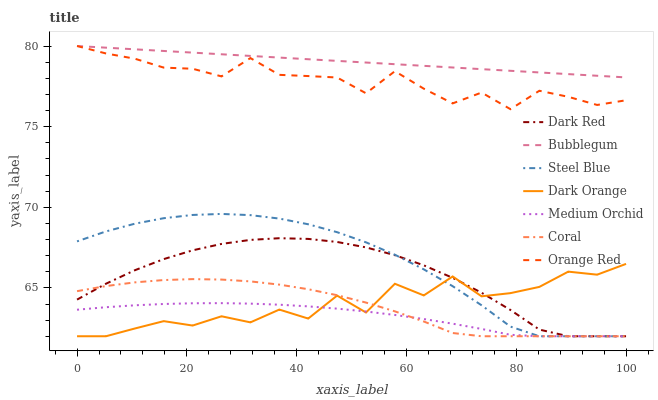Does Dark Red have the minimum area under the curve?
Answer yes or no. No. Does Dark Red have the maximum area under the curve?
Answer yes or no. No. Is Dark Red the smoothest?
Answer yes or no. No. Is Dark Red the roughest?
Answer yes or no. No. Does Bubblegum have the lowest value?
Answer yes or no. No. Does Dark Red have the highest value?
Answer yes or no. No. Is Coral less than Orange Red?
Answer yes or no. Yes. Is Bubblegum greater than Coral?
Answer yes or no. Yes. Does Coral intersect Orange Red?
Answer yes or no. No. 